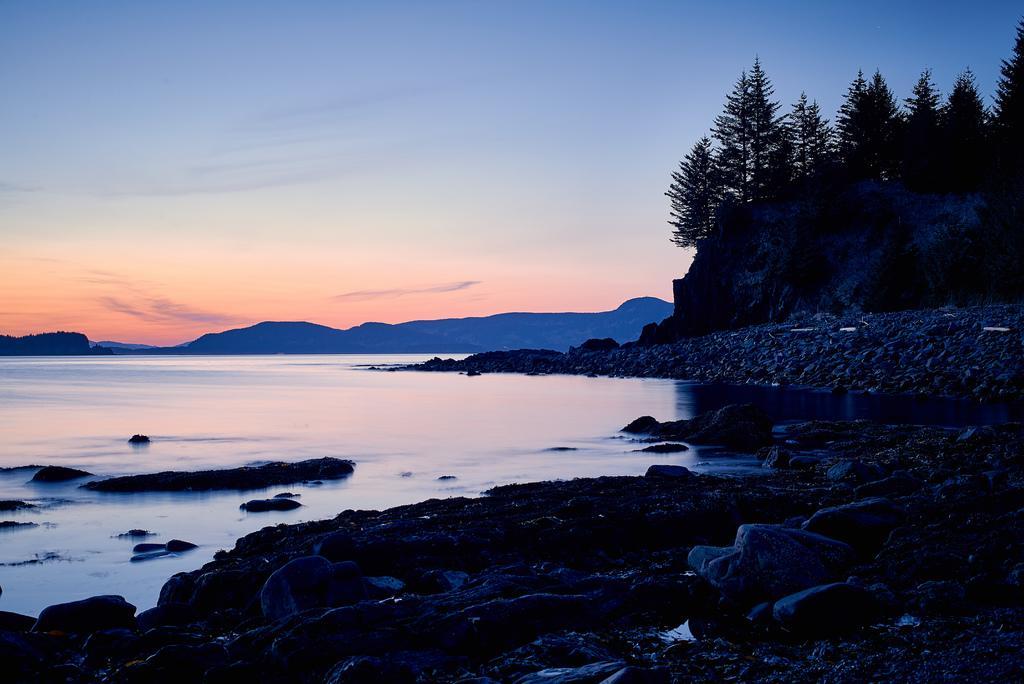Describe this image in one or two sentences. In this image we can see the water, beside the water, there are mountains, trees, rocks, stones and the sky. 